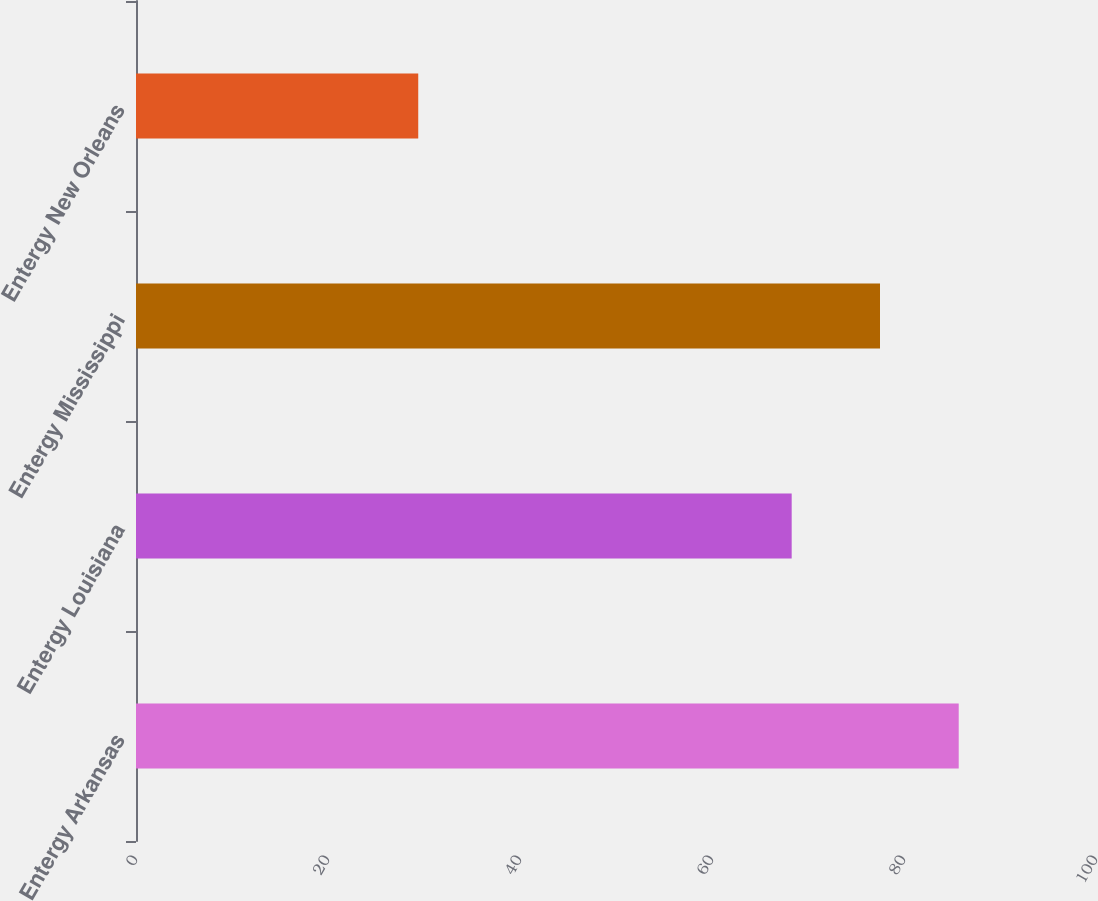Convert chart to OTSL. <chart><loc_0><loc_0><loc_500><loc_500><bar_chart><fcel>Entergy Arkansas<fcel>Entergy Louisiana<fcel>Entergy Mississippi<fcel>Entergy New Orleans<nl><fcel>85.7<fcel>68.3<fcel>77.5<fcel>29.4<nl></chart> 